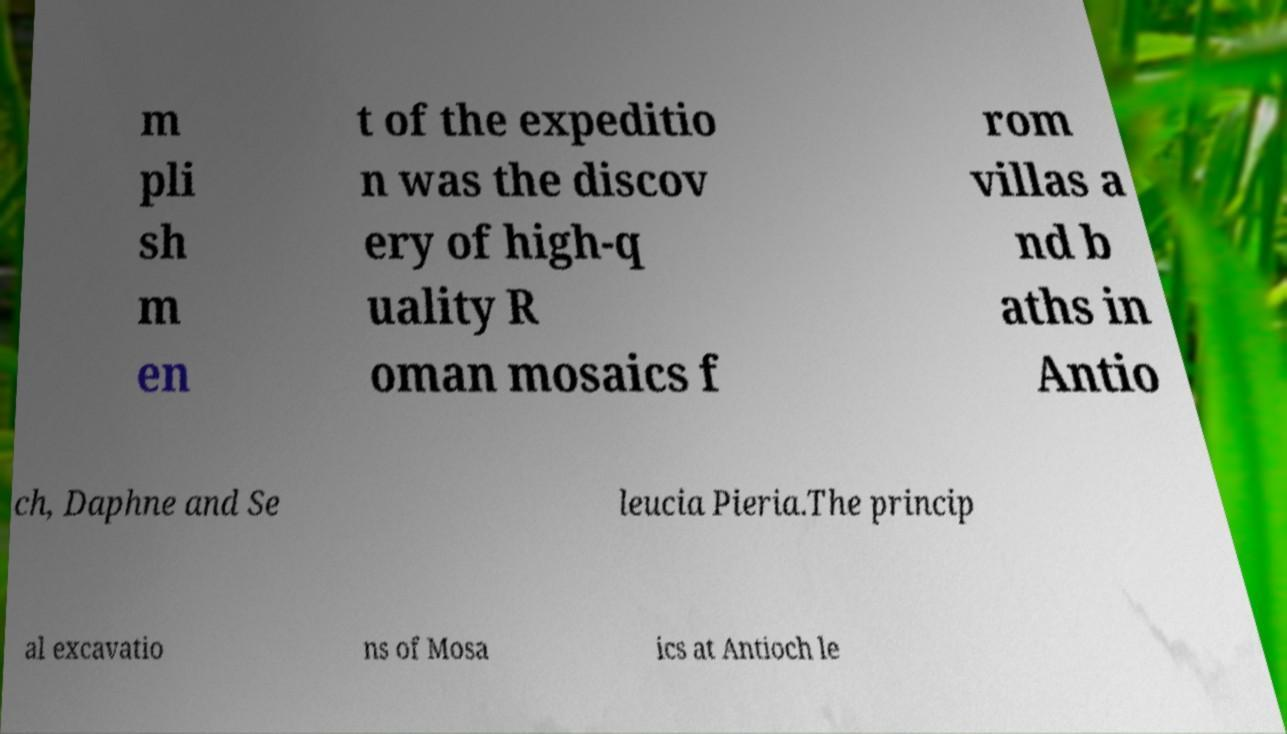Could you extract and type out the text from this image? m pli sh m en t of the expeditio n was the discov ery of high-q uality R oman mosaics f rom villas a nd b aths in Antio ch, Daphne and Se leucia Pieria.The princip al excavatio ns of Mosa ics at Antioch le 